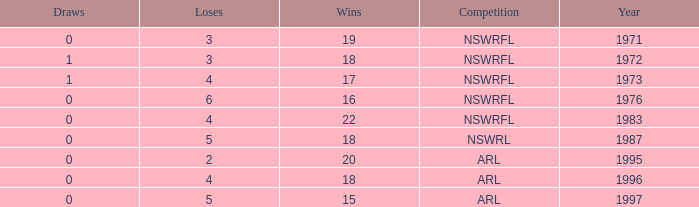What highest Year has Wins 15 and Losses less than 5? None. 